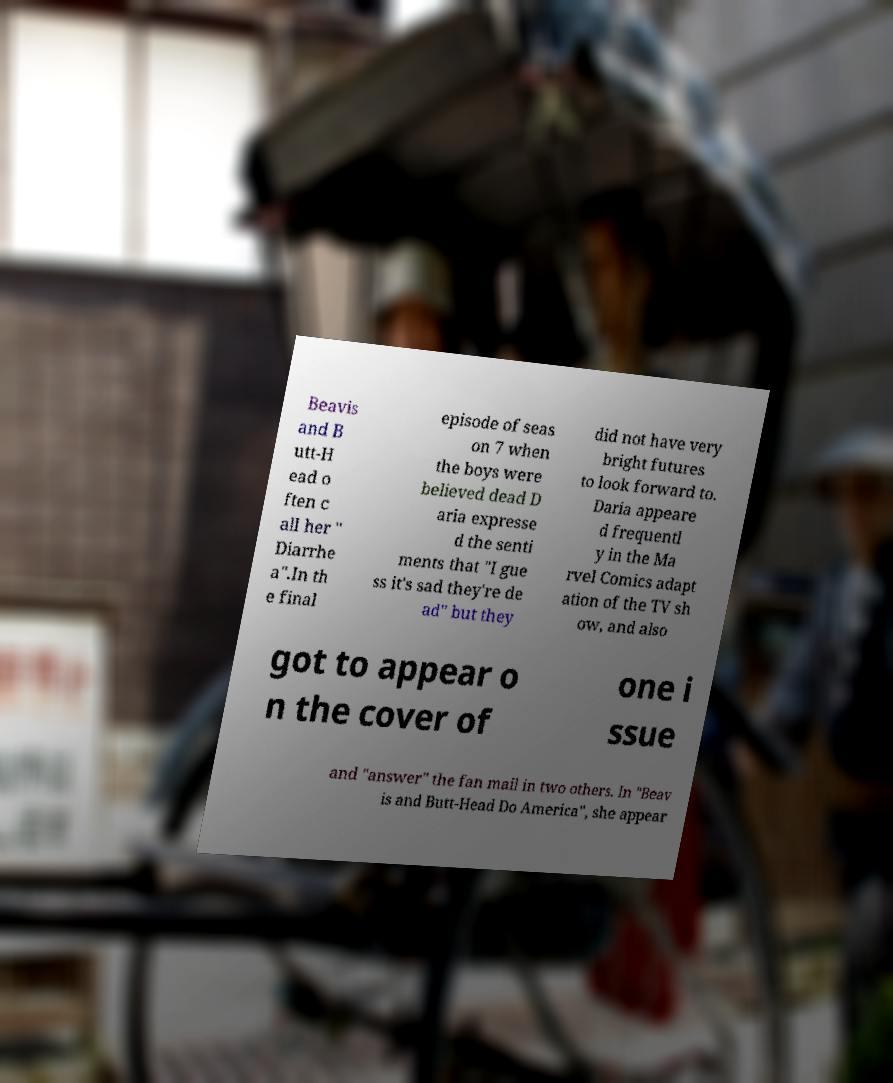Can you read and provide the text displayed in the image?This photo seems to have some interesting text. Can you extract and type it out for me? Beavis and B utt-H ead o ften c all her " Diarrhe a".In th e final episode of seas on 7 when the boys were believed dead D aria expresse d the senti ments that "I gue ss it's sad they're de ad" but they did not have very bright futures to look forward to. Daria appeare d frequentl y in the Ma rvel Comics adapt ation of the TV sh ow, and also got to appear o n the cover of one i ssue and "answer" the fan mail in two others. In "Beav is and Butt-Head Do America", she appear 